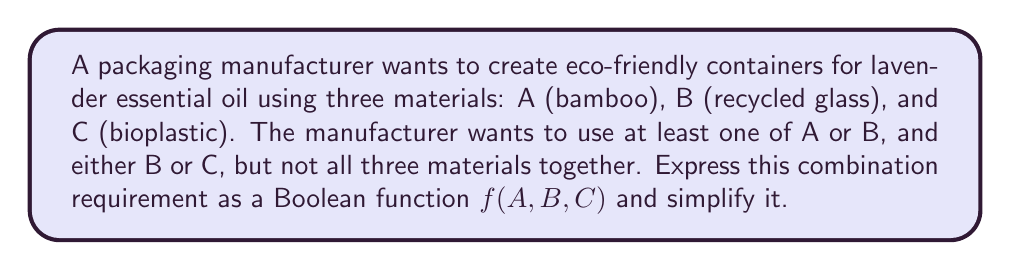Give your solution to this math problem. Let's approach this step-by-step:

1) First, let's express each condition as a Boolean expression:
   - At least one of A or B: $(A + B)$
   - Either B or C: $(B + C)$
   - Not all three materials together: $\overline{ABC}$

2) Combining these conditions with AND operations:
   $f(A,B,C) = (A + B) \cdot (B + C) \cdot \overline{ABC}$

3) Expand the first two terms:
   $f(A,B,C) = (AB + AC + B^2 + BC) \cdot \overline{ABC}$

4) Simplify $B^2$ to $B$:
   $f(A,B,C) = (AB + AC + B + BC) \cdot \overline{ABC}$

5) Distribute $\overline{ABC}$:
   $f(A,B,C) = AB\overline{ABC} + AC\overline{ABC} + B\overline{ABC} + BC\overline{ABC}$

6) Simplify each term:
   - $AB\overline{ABC} = AB\overline{C}$
   - $AC\overline{ABC} = AC\overline{B}$
   - $B\overline{ABC} = B\overline{AC}$
   - $BC\overline{ABC} = BC\overline{A}$

7) Combine the simplified terms:
   $f(A,B,C) = AB\overline{C} + AC\overline{B} + B\overline{AC} + BC\overline{A}$

This is the simplified Boolean function representing the required material combinations.
Answer: $f(A,B,C) = AB\overline{C} + AC\overline{B} + B\overline{AC} + BC\overline{A}$ 